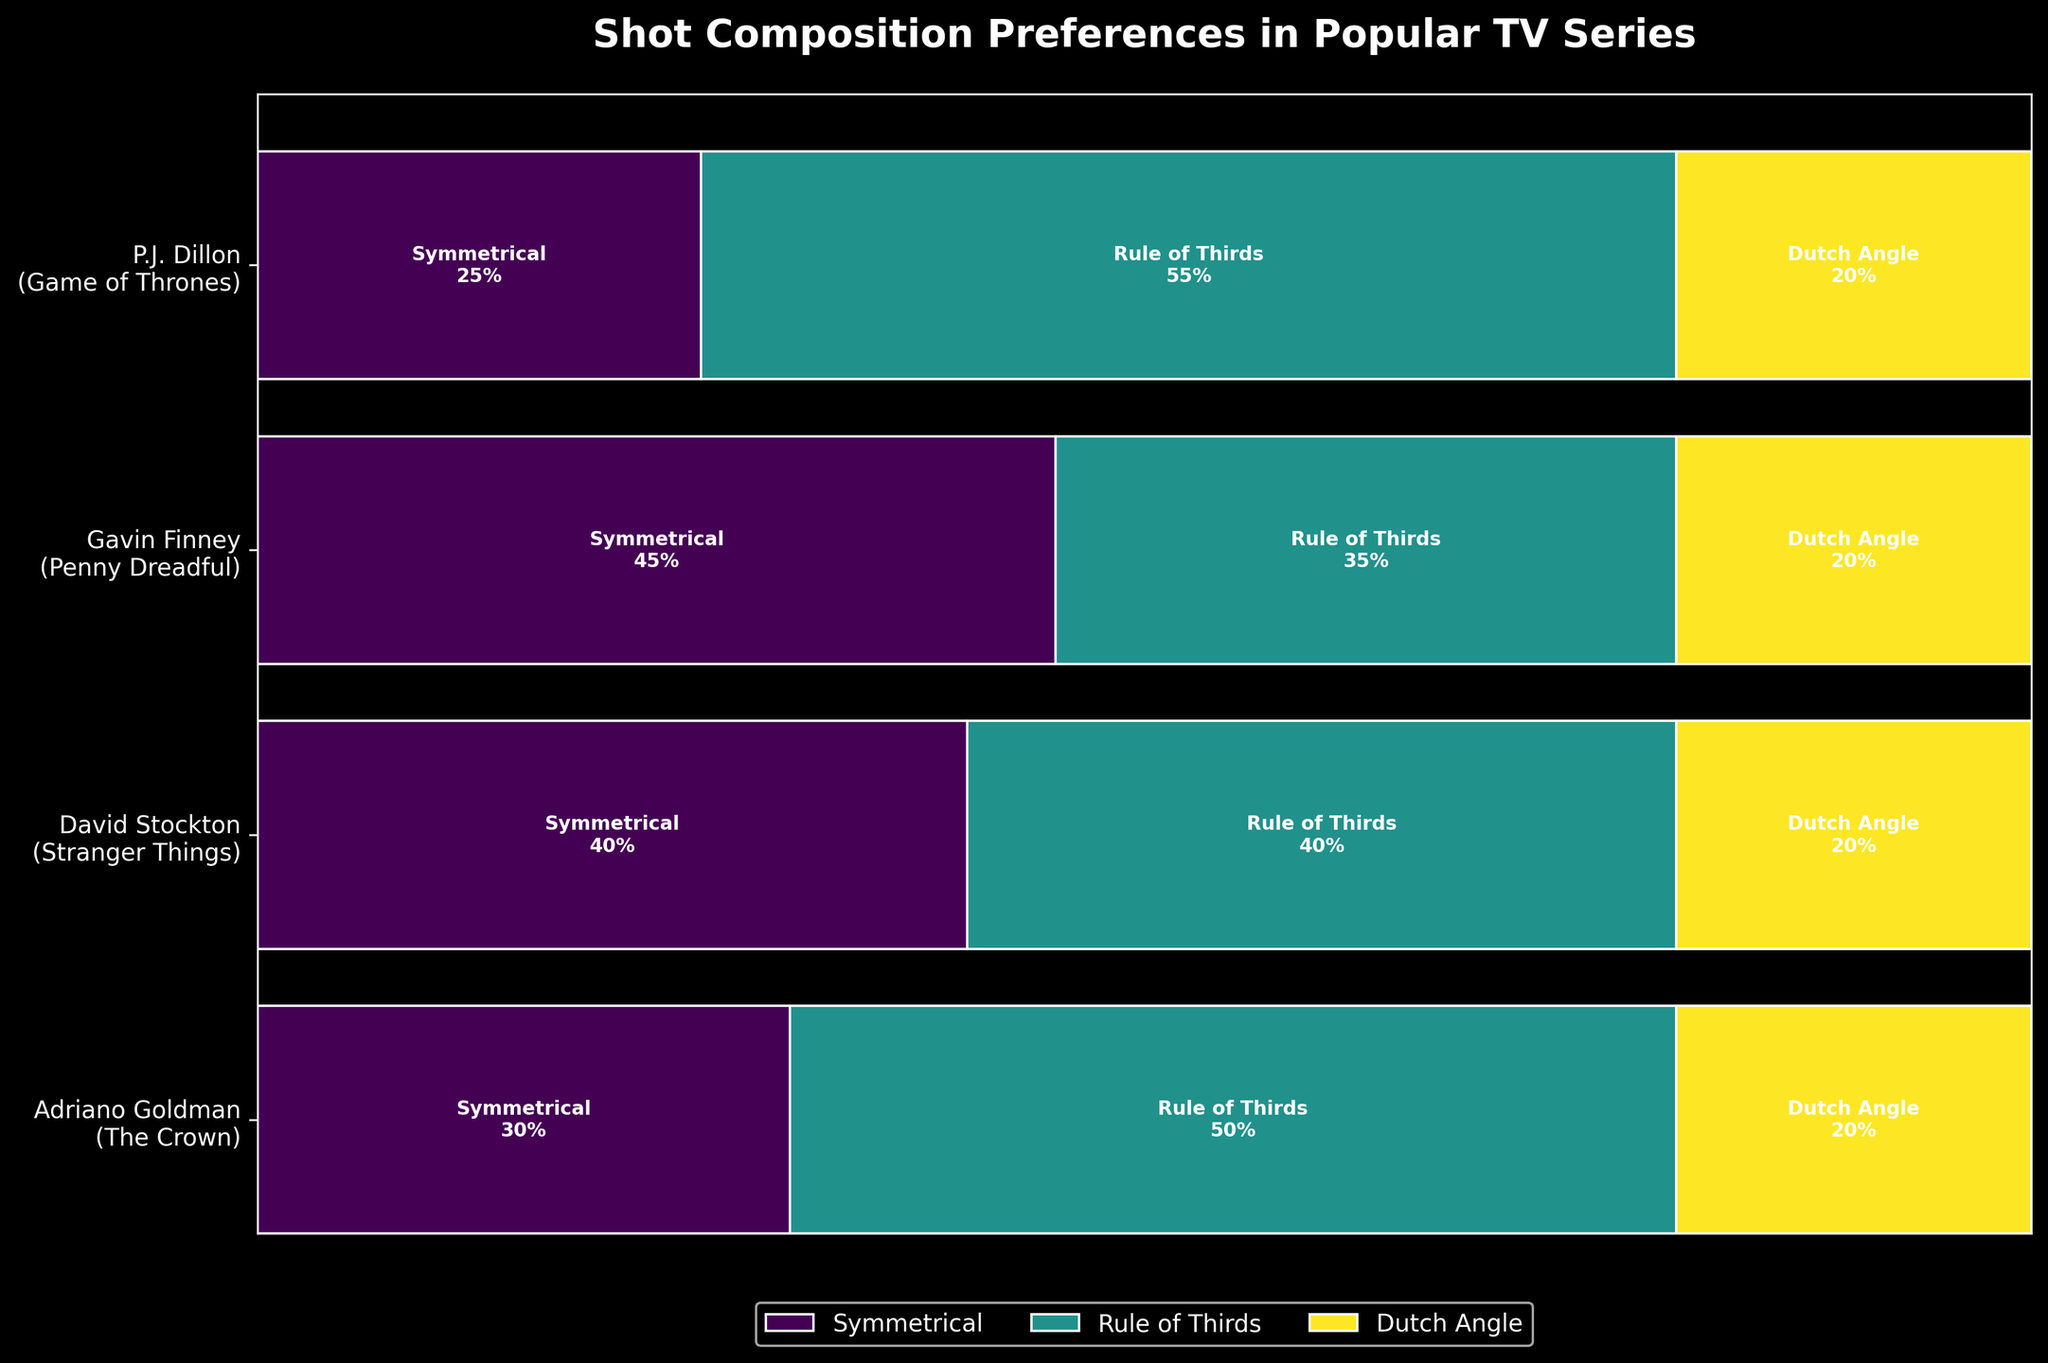What is the title of the plot? The title is usually located at the top of the plot. In this case, it reads "Shot Composition Preferences in Popular TV Series".
Answer: Shot Composition Preferences in Popular TV Series Which cinematographer prefers the Rule of Thirds the most for their series? Look at the width of the rectangles representing the Rule of Thirds in the middle portion for each cinematographer. P.J. Dillon's section has the widest rectangle for this style.
Answer: P.J. Dillon What percentage of Gavin Finney's compositions in Penny Dreadful are Dutch Angle? Check the text inside Gavin Finney's rectangles labeled Dutch Angle in the Penny Dreadful section. It shows 20%.
Answer: 20% How do the symmetric compositions in The Crown compare to those in Stranger Things? Compare the width of the rectangles for Symmetrical in The Crown and Stranger Things. The Crown's rectangle (30%) is narrower than Stranger Things' (40%).
Answer: Stranger Things has a higher percentage What style of composition accounts for the smallest percentage for all cinematographers? Look for the smallest slices across all rectangles. Dutch Angle is consistently the smallest at 20% for all.
Answer: Dutch Angle What is the combined percentage of Symmetrical compositions across all series? Add the percentages for Symmetrical for all series: 45% (Penny Dreadful) + 30% (The Crown) + 25% (Game of Thrones) + 40% (Stranger Things). This totals 140%, then divide by the number of cinematographers (4).
Answer: 35% How do Gavin Finney's composition preferences in Penny Dreadful differ from Adriano Goldman's in The Crown? Compare the sizes of the corresponding rectangles. Gavin Finney has more Symmetrical (45% vs 30%) and fewer Rule of Thirds (35% vs 50%) compositions than Adriano Goldman. Dutch Angle is the same at 20%.
Answer: Gavin Finney prefers more Symmetrical, fewer Rule of Thirds Which cinematographer has the most equal distribution among composition styles? Look for the cinematographer whose rectangles are most evenly sized. David Stockton shows near-equal widths in Stranger Things.
Answer: David Stockton 